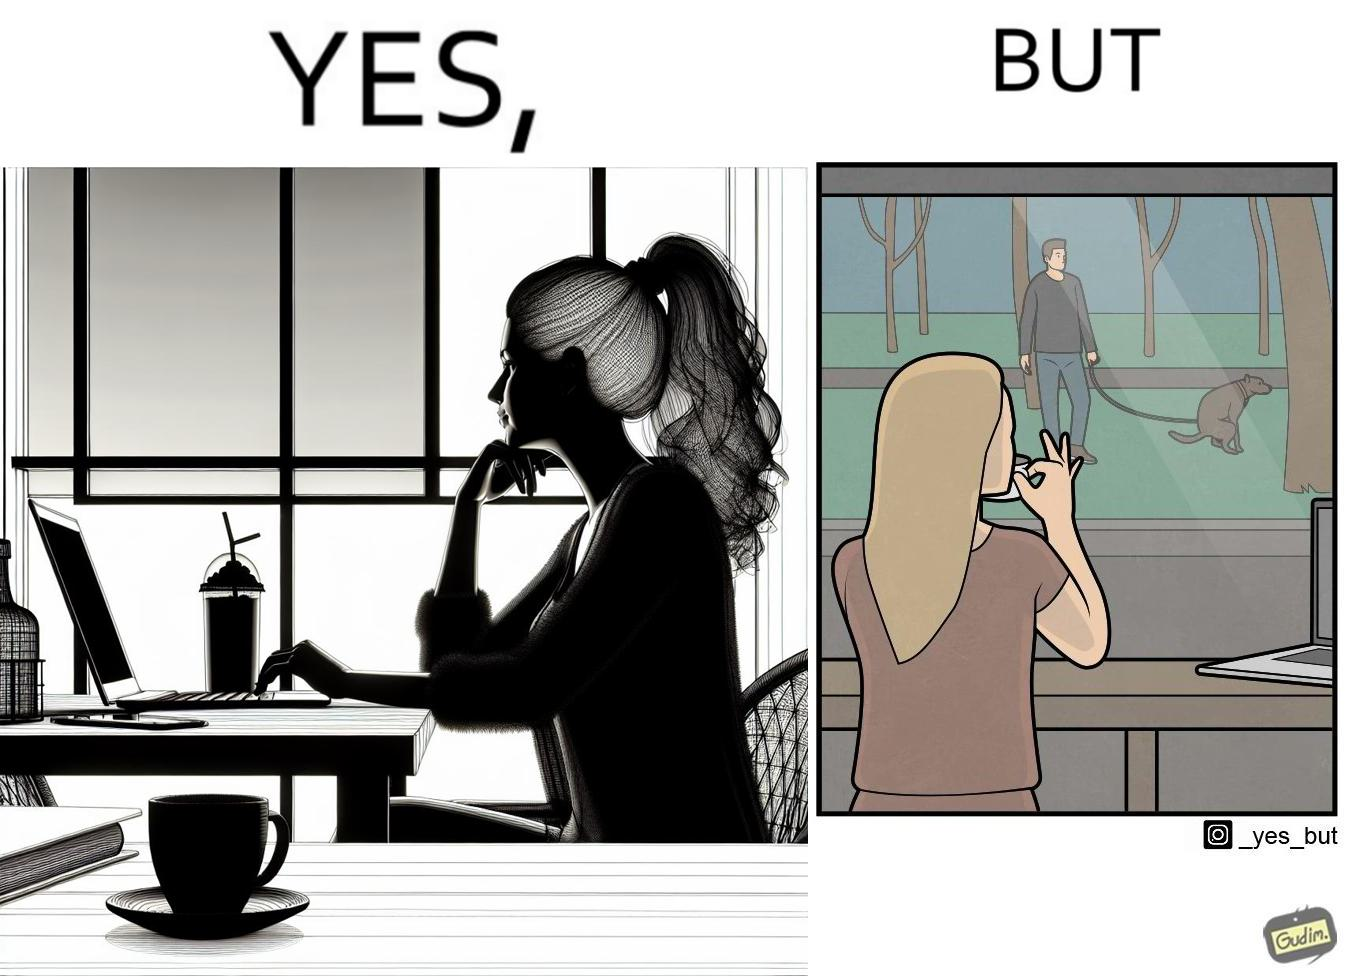Describe the contrast between the left and right parts of this image. In the left part of the image: a woman looking through the window from a cafe while enjoying her drink with working on her laptop In the right part of the image: a woman enjoying her drink and working at laptop while looking outside through the window at a person who is out for getting his dog pooped outside 